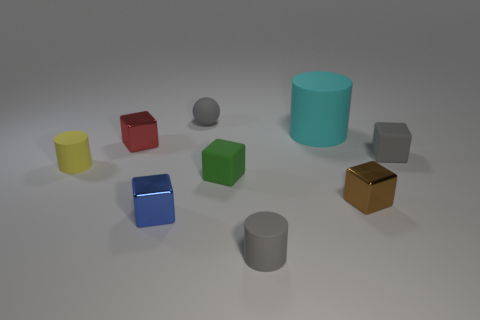Subtract all small gray matte cubes. How many cubes are left? 4 Subtract all gray blocks. How many blocks are left? 4 Subtract all yellow blocks. Subtract all brown cylinders. How many blocks are left? 5 Add 1 big cyan cubes. How many objects exist? 10 Subtract all cylinders. How many objects are left? 6 Subtract 0 yellow cubes. How many objects are left? 9 Subtract all red matte things. Subtract all cyan things. How many objects are left? 8 Add 1 small metal objects. How many small metal objects are left? 4 Add 9 small gray rubber blocks. How many small gray rubber blocks exist? 10 